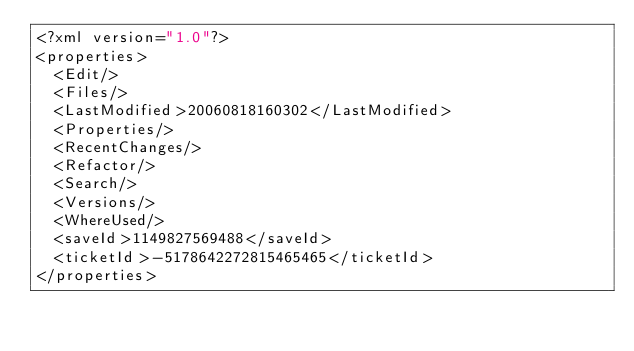Convert code to text. <code><loc_0><loc_0><loc_500><loc_500><_XML_><?xml version="1.0"?>
<properties>
	<Edit/>
	<Files/>
	<LastModified>20060818160302</LastModified>
	<Properties/>
	<RecentChanges/>
	<Refactor/>
	<Search/>
	<Versions/>
	<WhereUsed/>
	<saveId>1149827569488</saveId>
	<ticketId>-5178642272815465465</ticketId>
</properties>
</code> 